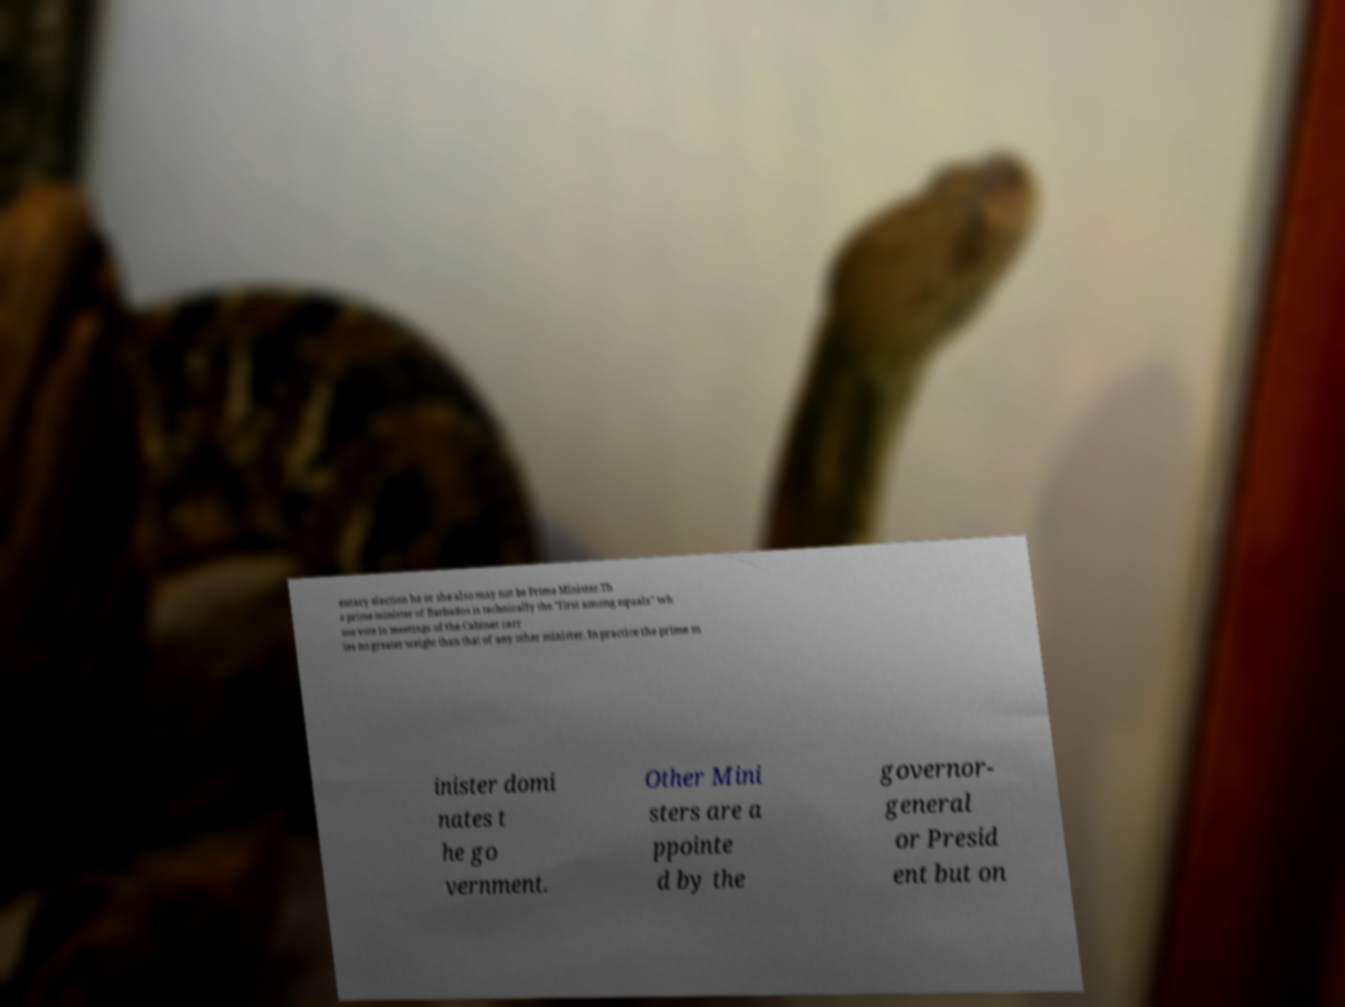What messages or text are displayed in this image? I need them in a readable, typed format. entary election he or she also may not be Prime Minister.Th e prime minister of Barbados is technically the "first among equals" wh ose vote in meetings of the Cabinet carr ies no greater weight than that of any other minister. In practice the prime m inister domi nates t he go vernment. Other Mini sters are a ppointe d by the governor- general or Presid ent but on 